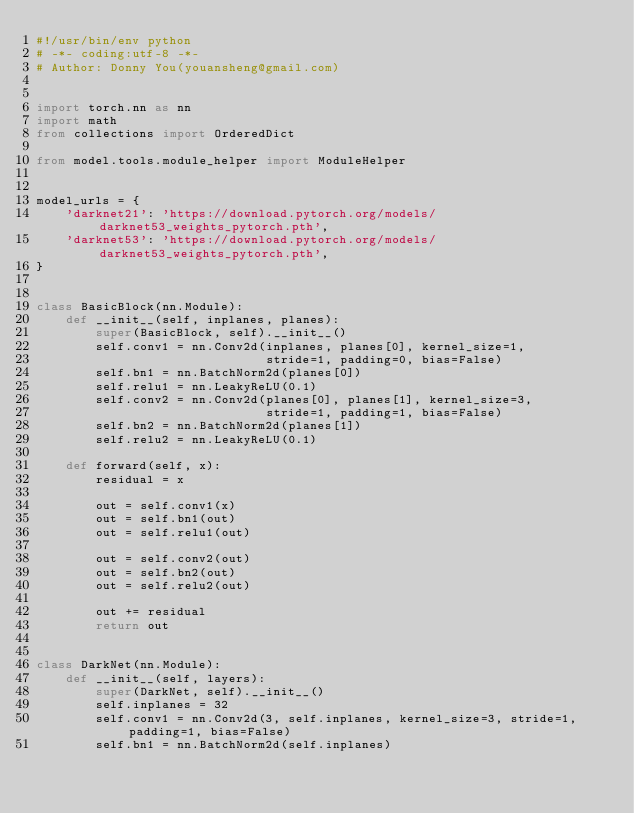<code> <loc_0><loc_0><loc_500><loc_500><_Python_>#!/usr/bin/env python
# -*- coding:utf-8 -*-
# Author: Donny You(youansheng@gmail.com)


import torch.nn as nn
import math
from collections import OrderedDict

from model.tools.module_helper import ModuleHelper


model_urls = {
    'darknet21': 'https://download.pytorch.org/models/darknet53_weights_pytorch.pth',
    'darknet53': 'https://download.pytorch.org/models/darknet53_weights_pytorch.pth',
}


class BasicBlock(nn.Module):
    def __init__(self, inplanes, planes):
        super(BasicBlock, self).__init__()
        self.conv1 = nn.Conv2d(inplanes, planes[0], kernel_size=1,
                               stride=1, padding=0, bias=False)
        self.bn1 = nn.BatchNorm2d(planes[0])
        self.relu1 = nn.LeakyReLU(0.1)
        self.conv2 = nn.Conv2d(planes[0], planes[1], kernel_size=3,
                               stride=1, padding=1, bias=False)
        self.bn2 = nn.BatchNorm2d(planes[1])
        self.relu2 = nn.LeakyReLU(0.1)

    def forward(self, x):
        residual = x

        out = self.conv1(x)
        out = self.bn1(out)
        out = self.relu1(out)

        out = self.conv2(out)
        out = self.bn2(out)
        out = self.relu2(out)

        out += residual
        return out


class DarkNet(nn.Module):
    def __init__(self, layers):
        super(DarkNet, self).__init__()
        self.inplanes = 32
        self.conv1 = nn.Conv2d(3, self.inplanes, kernel_size=3, stride=1, padding=1, bias=False)
        self.bn1 = nn.BatchNorm2d(self.inplanes)</code> 